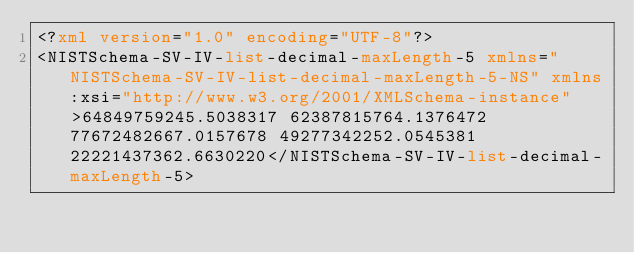<code> <loc_0><loc_0><loc_500><loc_500><_XML_><?xml version="1.0" encoding="UTF-8"?>
<NISTSchema-SV-IV-list-decimal-maxLength-5 xmlns="NISTSchema-SV-IV-list-decimal-maxLength-5-NS" xmlns:xsi="http://www.w3.org/2001/XMLSchema-instance">64849759245.5038317 62387815764.1376472 77672482667.0157678 49277342252.0545381 22221437362.6630220</NISTSchema-SV-IV-list-decimal-maxLength-5>
</code> 